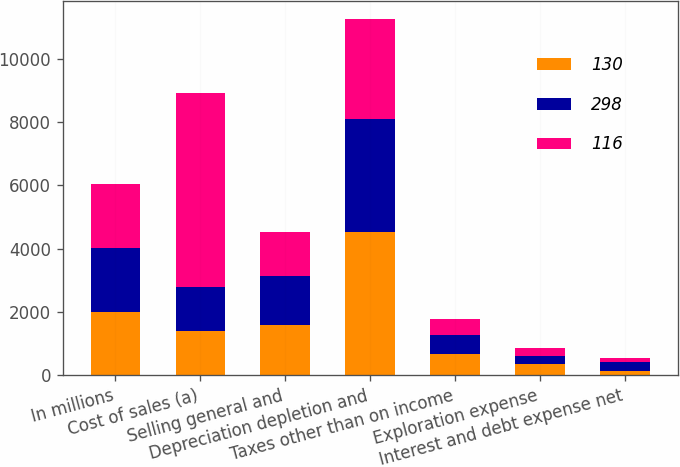Convert chart. <chart><loc_0><loc_0><loc_500><loc_500><stacked_bar_chart><ecel><fcel>In millions<fcel>Cost of sales (a)<fcel>Selling general and<fcel>Depreciation depletion and<fcel>Taxes other than on income<fcel>Exploration expense<fcel>Interest and debt expense net<nl><fcel>130<fcel>2012<fcel>1396<fcel>1602<fcel>4511<fcel>680<fcel>345<fcel>130<nl><fcel>298<fcel>2011<fcel>1396<fcel>1523<fcel>3591<fcel>605<fcel>258<fcel>298<nl><fcel>116<fcel>2010<fcel>6112<fcel>1396<fcel>3153<fcel>484<fcel>262<fcel>116<nl></chart> 